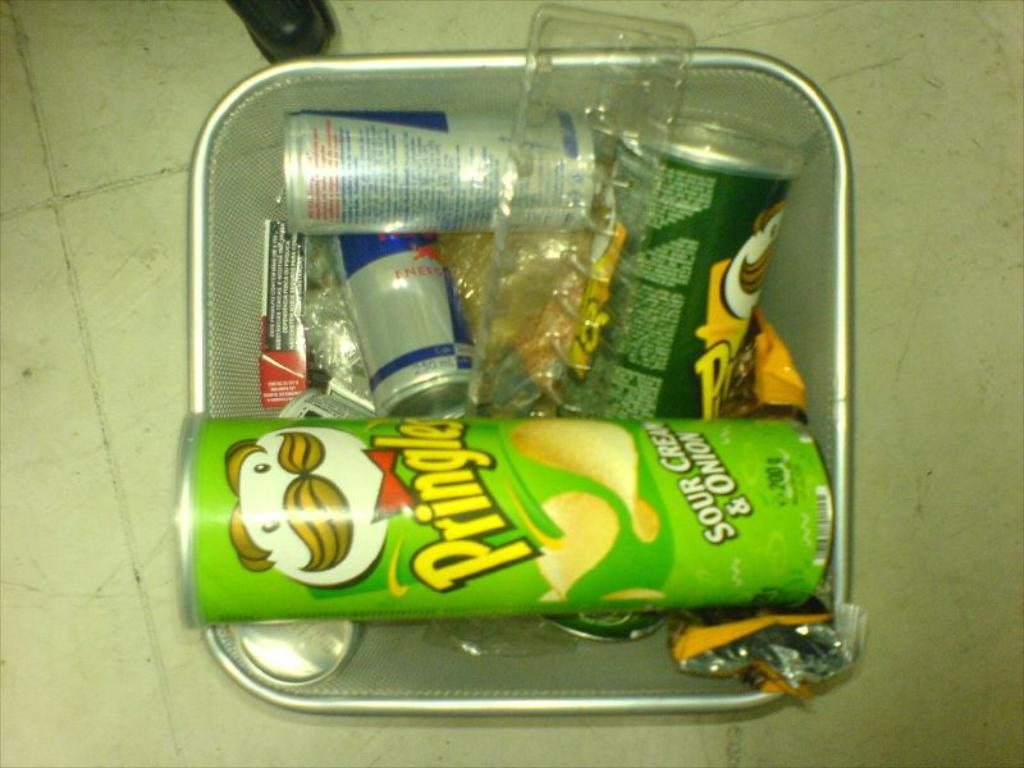What is the main object in the image? There is a box in the image. What is inside the box? The box is filled with bottles. Where is the box located? The box is placed on the floor. What type of pancake is being prepared by the mom in the image? There is no mom or pancake present in the image; it only features a box filled with bottles placed on the floor. 